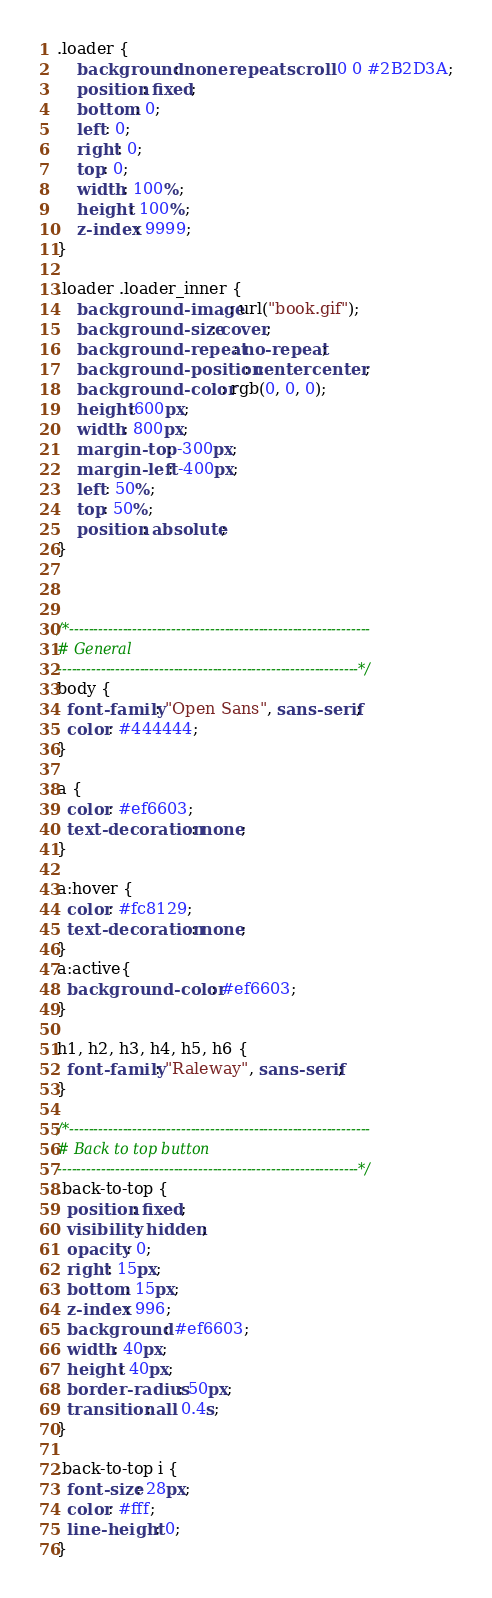<code> <loc_0><loc_0><loc_500><loc_500><_CSS_>
.loader {
	background: none repeat scroll 0 0 #2B2D3A;
	position: fixed;
	bottom: 0;
	left: 0;
	right: 0;
	top: 0;
	width: 100%;
	height: 100%;
	z-index: 9999; 
}

.loader .loader_inner {
	background-image: url("book.gif");
	background-size: cover;
	background-repeat: no-repeat;
	background-position: center center;
	background-color: rgb(0, 0, 0);
	height:600px;
	width: 800px;
	margin-top: -300px;
	margin-left: -400px;
	left: 50%;
	top: 50%;
	position: absolute; 
}



/*--------------------------------------------------------------
# General
--------------------------------------------------------------*/
body {
  font-family: "Open Sans", sans-serif;
  color: #444444;
}

a {
  color: #ef6603;
  text-decoration: none;
}

a:hover {
  color: #fc8129;
  text-decoration: none;
}
a:active{
  background-color: #ef6603;
}

h1, h2, h3, h4, h5, h6 {
  font-family: "Raleway", sans-serif;
}

/*--------------------------------------------------------------
# Back to top button
--------------------------------------------------------------*/
.back-to-top {
  position: fixed;
  visibility: hidden;
  opacity: 0;
  right: 15px;
  bottom: 15px;
  z-index: 996;
  background: #ef6603;
  width: 40px;
  height: 40px;
  border-radius: 50px;
  transition: all 0.4s;
}

.back-to-top i {
  font-size: 28px;
  color: #fff;
  line-height: 0;
}
</code> 